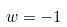Convert formula to latex. <formula><loc_0><loc_0><loc_500><loc_500>w = - 1</formula> 